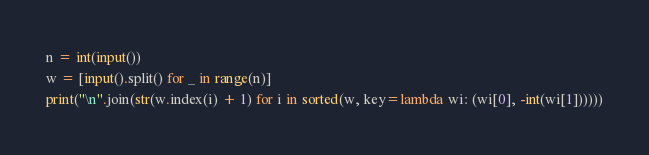Convert code to text. <code><loc_0><loc_0><loc_500><loc_500><_Python_>n = int(input())
w = [input().split() for _ in range(n)]
print("\n".join(str(w.index(i) + 1) for i in sorted(w, key=lambda wi: (wi[0], -int(wi[1])))))</code> 